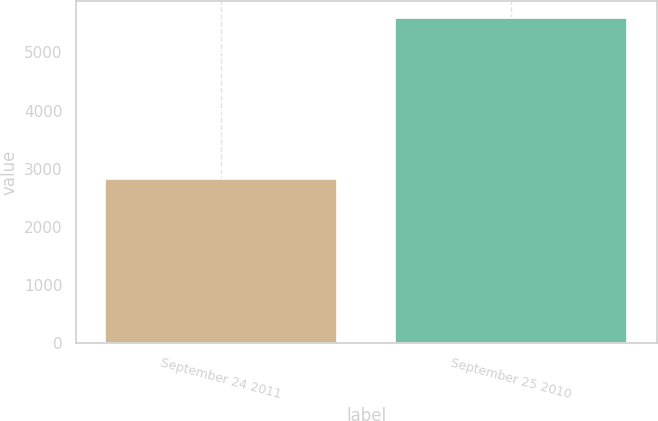Convert chart to OTSL. <chart><loc_0><loc_0><loc_500><loc_500><bar_chart><fcel>September 24 2011<fcel>September 25 2010<nl><fcel>2830<fcel>5602<nl></chart> 